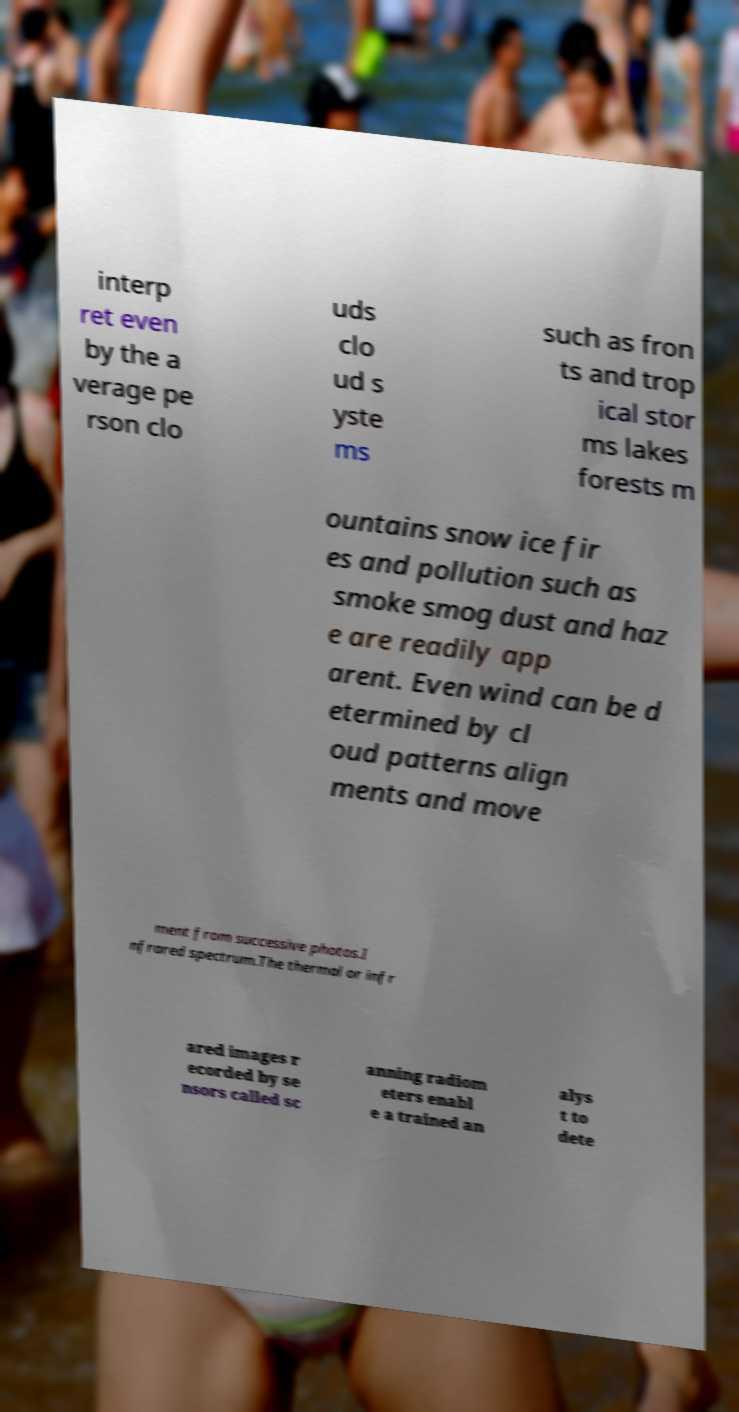Could you assist in decoding the text presented in this image and type it out clearly? interp ret even by the a verage pe rson clo uds clo ud s yste ms such as fron ts and trop ical stor ms lakes forests m ountains snow ice fir es and pollution such as smoke smog dust and haz e are readily app arent. Even wind can be d etermined by cl oud patterns align ments and move ment from successive photos.I nfrared spectrum.The thermal or infr ared images r ecorded by se nsors called sc anning radiom eters enabl e a trained an alys t to dete 